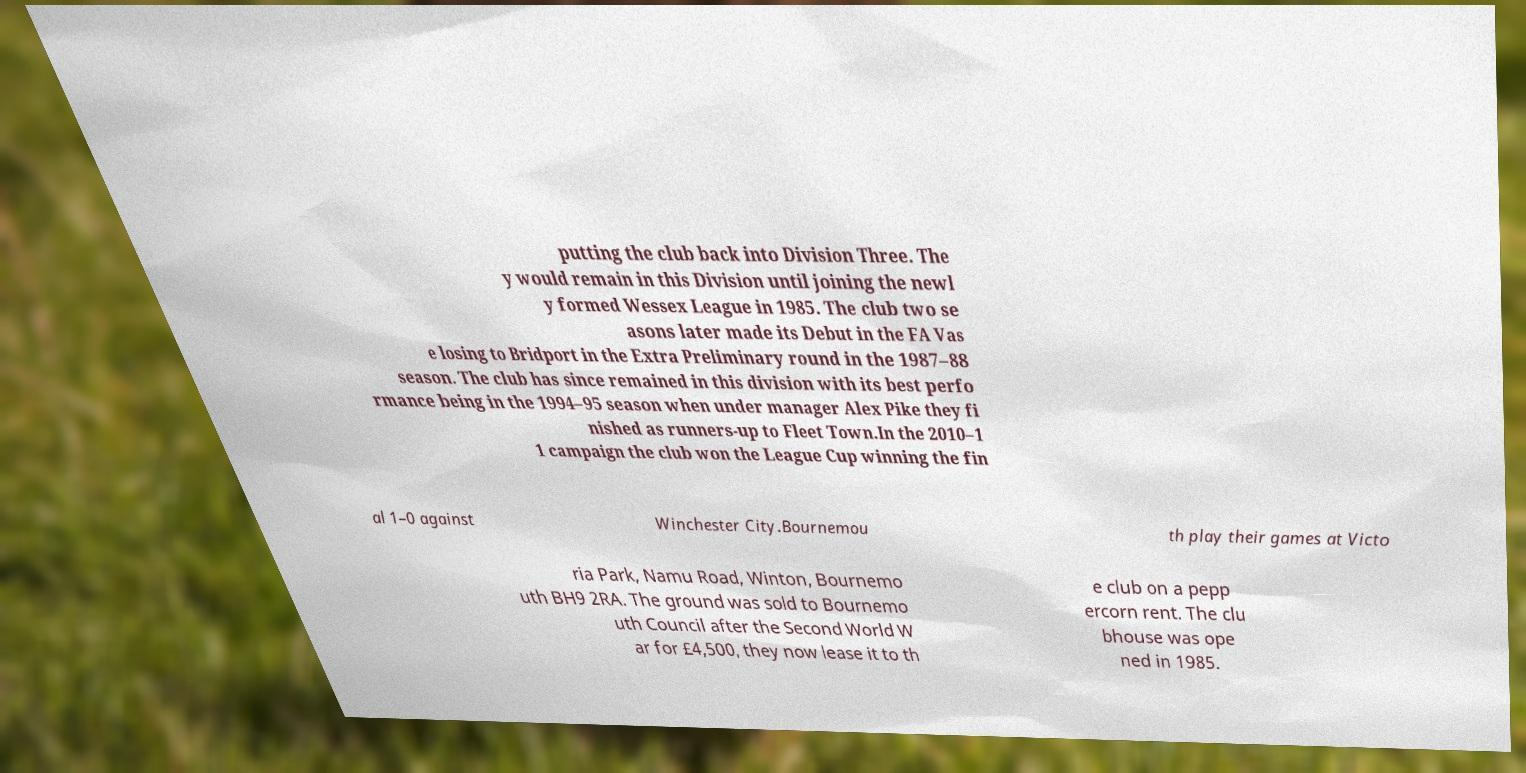Could you extract and type out the text from this image? putting the club back into Division Three. The y would remain in this Division until joining the newl y formed Wessex League in 1985. The club two se asons later made its Debut in the FA Vas e losing to Bridport in the Extra Preliminary round in the 1987–88 season. The club has since remained in this division with its best perfo rmance being in the 1994–95 season when under manager Alex Pike they fi nished as runners-up to Fleet Town.In the 2010–1 1 campaign the club won the League Cup winning the fin al 1–0 against Winchester City.Bournemou th play their games at Victo ria Park, Namu Road, Winton, Bournemo uth BH9 2RA. The ground was sold to Bournemo uth Council after the Second World W ar for £4,500, they now lease it to th e club on a pepp ercorn rent. The clu bhouse was ope ned in 1985. 